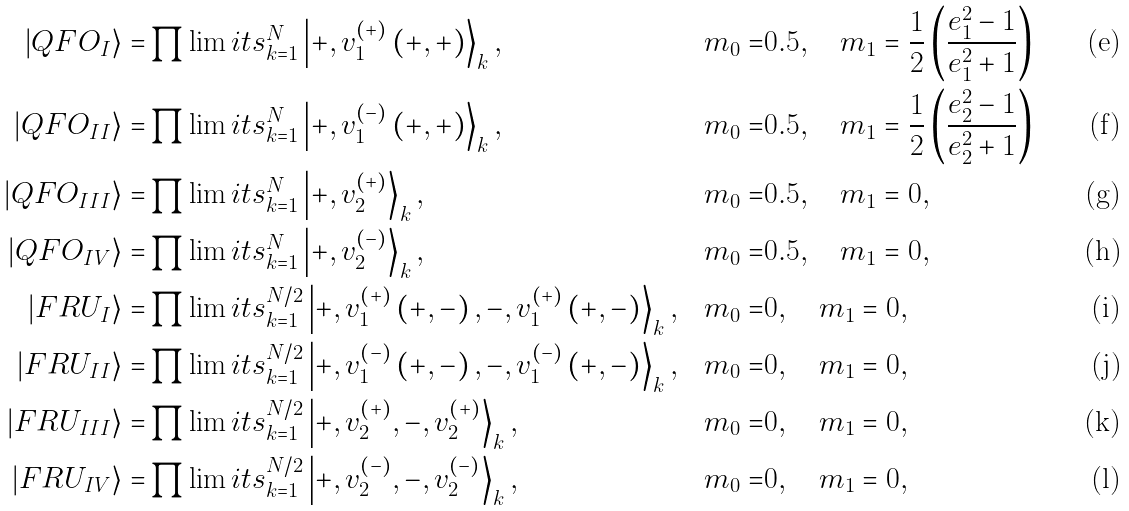<formula> <loc_0><loc_0><loc_500><loc_500>\left | Q F O _ { I } \right \rangle = & \prod \lim i t s _ { k = 1 } ^ { N } \left | + , v _ { 1 } ^ { ( + ) } \left ( + , + \right ) \right \rangle _ { k } , & m _ { 0 } = & 0 . 5 , \quad m _ { 1 } = \frac { 1 } { 2 } \left ( \frac { e _ { 1 } ^ { 2 } - 1 } { e _ { 1 } ^ { 2 } + 1 } \right ) & \\ | Q F O _ { I I } \rangle = & \prod \lim i t s _ { k = 1 } ^ { N } \left | + , v _ { 1 } ^ { \left ( - \right ) } \left ( + , + \right ) \right \rangle _ { k } , & m _ { 0 } = & 0 . 5 , \quad m _ { 1 } = \frac { 1 } { 2 } \left ( \frac { e _ { 2 } ^ { 2 } - 1 } { e _ { 2 } ^ { 2 } + 1 } \right ) & \\ | Q F O _ { I I I } \rangle = & \prod \lim i t s _ { k = 1 } ^ { N } \left | + , v _ { 2 } ^ { \left ( + \right ) } \right \rangle _ { k } , & m _ { 0 } = & 0 . 5 , \quad m _ { 1 } = 0 , & \\ | Q F O _ { I V } \rangle = & \prod \lim i t s _ { k = 1 } ^ { N } \left | + , v _ { 2 } ^ { \left ( - \right ) } \right \rangle _ { k } , & m _ { 0 } = & 0 . 5 , \quad m _ { 1 } = 0 , & \\ | F R U _ { I } \rangle = & \prod \lim i t s _ { k = 1 } ^ { N / 2 } \left | + , v _ { 1 } ^ { \left ( + \right ) } \left ( + , - \right ) , - , v _ { 1 } ^ { \left ( + \right ) } \left ( + , - \right ) \right \rangle _ { k } , & m _ { 0 } = & 0 , \quad m _ { 1 } = 0 , & \\ | F R U _ { I I } \rangle = & \prod \lim i t s _ { k = 1 } ^ { N / 2 } \left | + , v _ { 1 } ^ { \left ( - \right ) } \left ( + , - \right ) , - , v _ { 1 } ^ { \left ( - \right ) } \left ( + , - \right ) \right \rangle _ { k } , & m _ { 0 } = & 0 , \quad m _ { 1 } = 0 , & \\ | F R U _ { I I I } \rangle = & \prod \lim i t s _ { k = 1 } ^ { N / 2 } \left | + , v _ { 2 } ^ { \left ( + \right ) } , - , v _ { 2 } ^ { \left ( + \right ) } \right \rangle _ { k } , & m _ { 0 } = & 0 , \quad m _ { 1 } = 0 , & \\ | F R U _ { I V } \rangle = & \prod \lim i t s _ { k = 1 } ^ { N / 2 } \left | + , v _ { 2 } ^ { \left ( - \right ) } , - , v _ { 2 } ^ { ( - ) } \right \rangle _ { k } , & m _ { 0 } = & 0 , \quad m _ { 1 } = 0 , &</formula> 